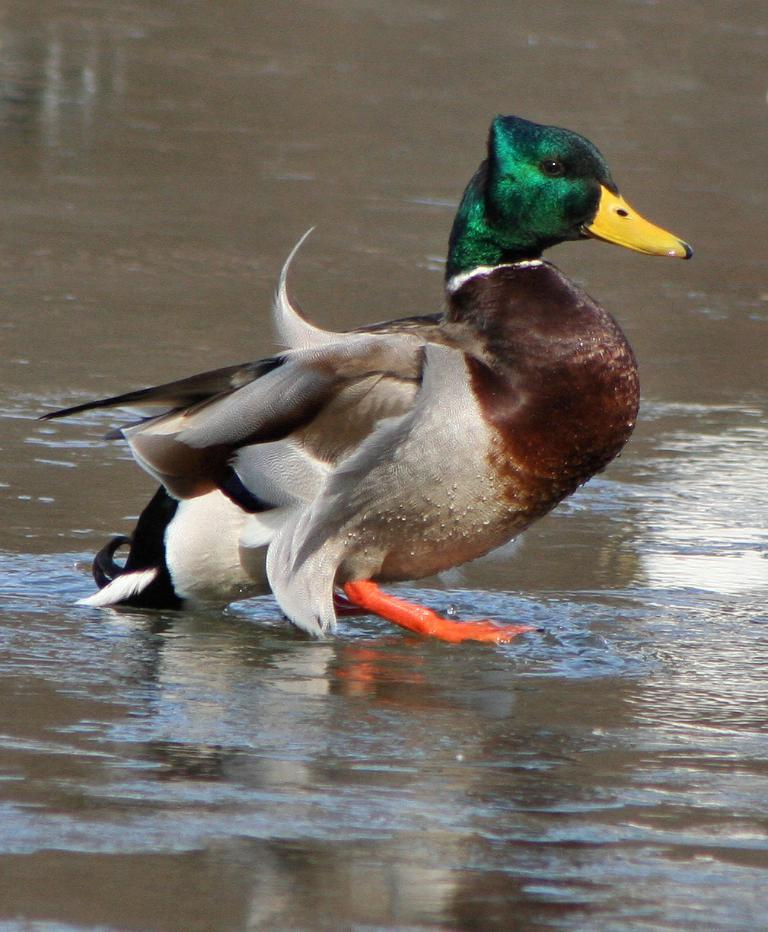What animal is present in the image? There is a duck in the image. Where is the duck located? The duck is in the water. How many family members are shown eating pie on bikes in the image? There are no family members, pie, or bikes present in the image; it only features a duck in the water. 